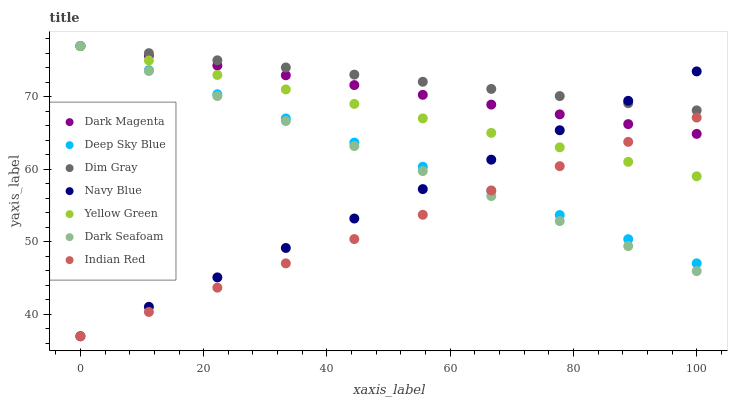Does Indian Red have the minimum area under the curve?
Answer yes or no. Yes. Does Dim Gray have the maximum area under the curve?
Answer yes or no. Yes. Does Dark Magenta have the minimum area under the curve?
Answer yes or no. No. Does Dark Magenta have the maximum area under the curve?
Answer yes or no. No. Is Indian Red the smoothest?
Answer yes or no. Yes. Is Dark Magenta the roughest?
Answer yes or no. Yes. Is Navy Blue the smoothest?
Answer yes or no. No. Is Navy Blue the roughest?
Answer yes or no. No. Does Navy Blue have the lowest value?
Answer yes or no. Yes. Does Dark Magenta have the lowest value?
Answer yes or no. No. Does Yellow Green have the highest value?
Answer yes or no. Yes. Does Navy Blue have the highest value?
Answer yes or no. No. Is Indian Red less than Dim Gray?
Answer yes or no. Yes. Is Dim Gray greater than Indian Red?
Answer yes or no. Yes. Does Indian Red intersect Dark Magenta?
Answer yes or no. Yes. Is Indian Red less than Dark Magenta?
Answer yes or no. No. Is Indian Red greater than Dark Magenta?
Answer yes or no. No. Does Indian Red intersect Dim Gray?
Answer yes or no. No. 